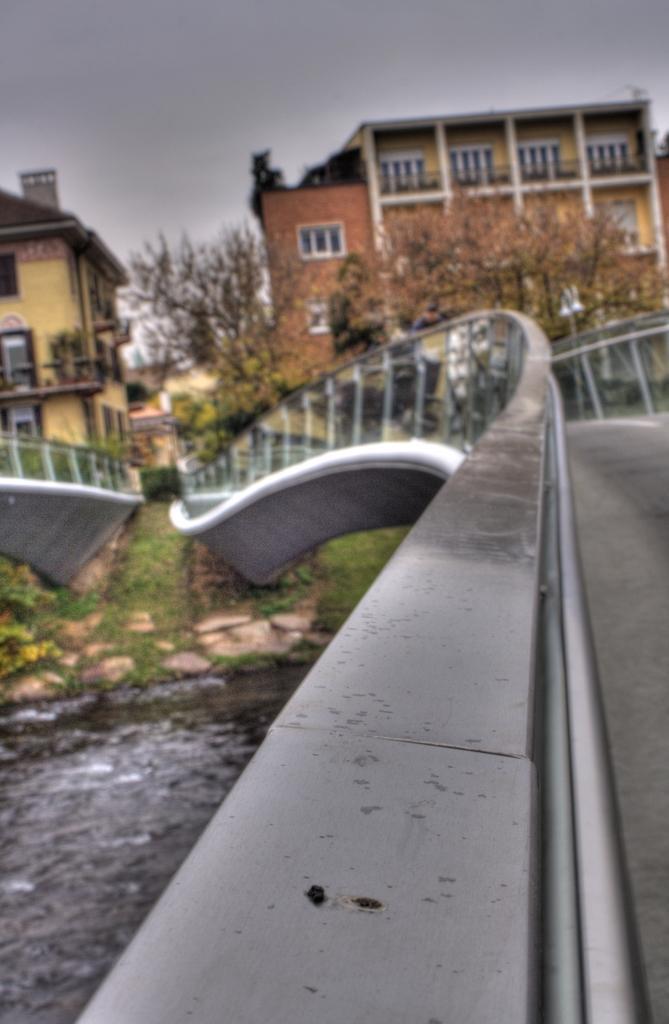Describe this image in one or two sentences. In this image there are bridges, water, grass, plants, trees, buildings,sky. 